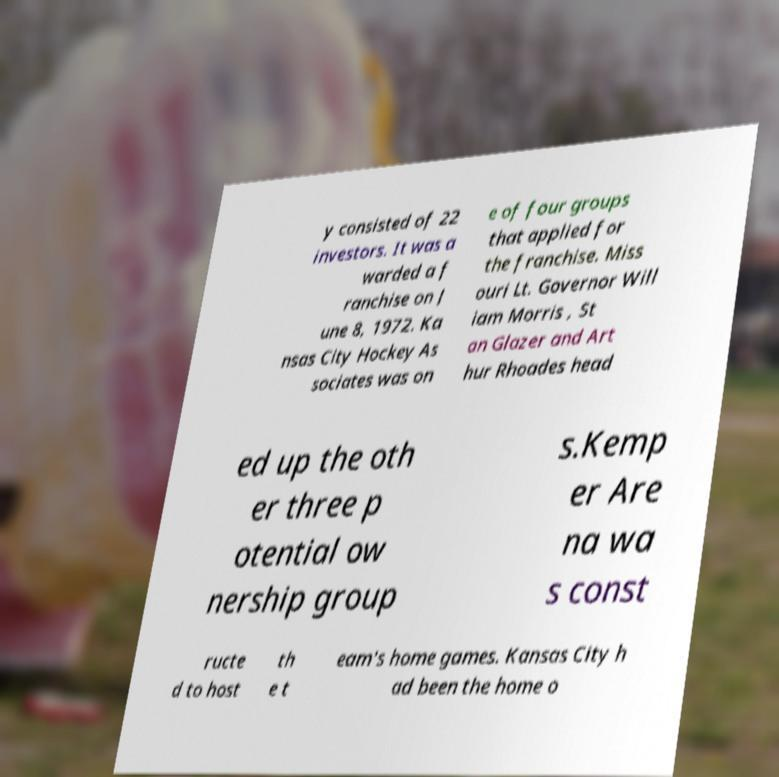There's text embedded in this image that I need extracted. Can you transcribe it verbatim? y consisted of 22 investors. It was a warded a f ranchise on J une 8, 1972. Ka nsas City Hockey As sociates was on e of four groups that applied for the franchise. Miss ouri Lt. Governor Will iam Morris , St an Glazer and Art hur Rhoades head ed up the oth er three p otential ow nership group s.Kemp er Are na wa s const ructe d to host th e t eam's home games. Kansas City h ad been the home o 